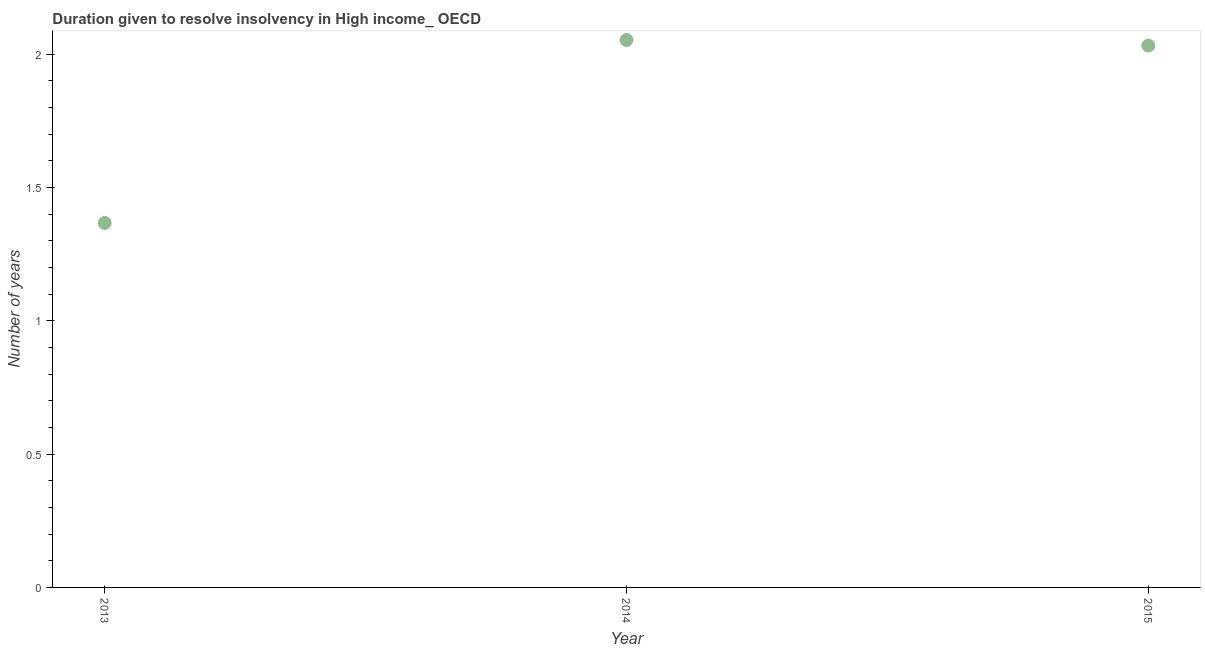What is the number of years to resolve insolvency in 2014?
Provide a succinct answer. 2.05. Across all years, what is the maximum number of years to resolve insolvency?
Offer a very short reply. 2.05. Across all years, what is the minimum number of years to resolve insolvency?
Provide a short and direct response. 1.37. What is the sum of the number of years to resolve insolvency?
Give a very brief answer. 5.45. What is the difference between the number of years to resolve insolvency in 2013 and 2015?
Keep it short and to the point. -0.66. What is the average number of years to resolve insolvency per year?
Ensure brevity in your answer.  1.82. What is the median number of years to resolve insolvency?
Make the answer very short. 2.03. Do a majority of the years between 2015 and 2014 (inclusive) have number of years to resolve insolvency greater than 1.1 ?
Your answer should be compact. No. What is the ratio of the number of years to resolve insolvency in 2013 to that in 2014?
Give a very brief answer. 0.67. Is the number of years to resolve insolvency in 2013 less than that in 2014?
Offer a very short reply. Yes. What is the difference between the highest and the second highest number of years to resolve insolvency?
Provide a succinct answer. 0.02. What is the difference between the highest and the lowest number of years to resolve insolvency?
Your answer should be compact. 0.69. In how many years, is the number of years to resolve insolvency greater than the average number of years to resolve insolvency taken over all years?
Provide a short and direct response. 2. How many years are there in the graph?
Ensure brevity in your answer.  3. What is the difference between two consecutive major ticks on the Y-axis?
Your response must be concise. 0.5. What is the title of the graph?
Offer a terse response. Duration given to resolve insolvency in High income_ OECD. What is the label or title of the Y-axis?
Your answer should be very brief. Number of years. What is the Number of years in 2013?
Ensure brevity in your answer.  1.37. What is the Number of years in 2014?
Your answer should be compact. 2.05. What is the Number of years in 2015?
Provide a short and direct response. 2.03. What is the difference between the Number of years in 2013 and 2014?
Make the answer very short. -0.69. What is the difference between the Number of years in 2013 and 2015?
Provide a short and direct response. -0.66. What is the difference between the Number of years in 2014 and 2015?
Provide a short and direct response. 0.02. What is the ratio of the Number of years in 2013 to that in 2014?
Your response must be concise. 0.67. What is the ratio of the Number of years in 2013 to that in 2015?
Provide a short and direct response. 0.67. What is the ratio of the Number of years in 2014 to that in 2015?
Provide a short and direct response. 1.01. 